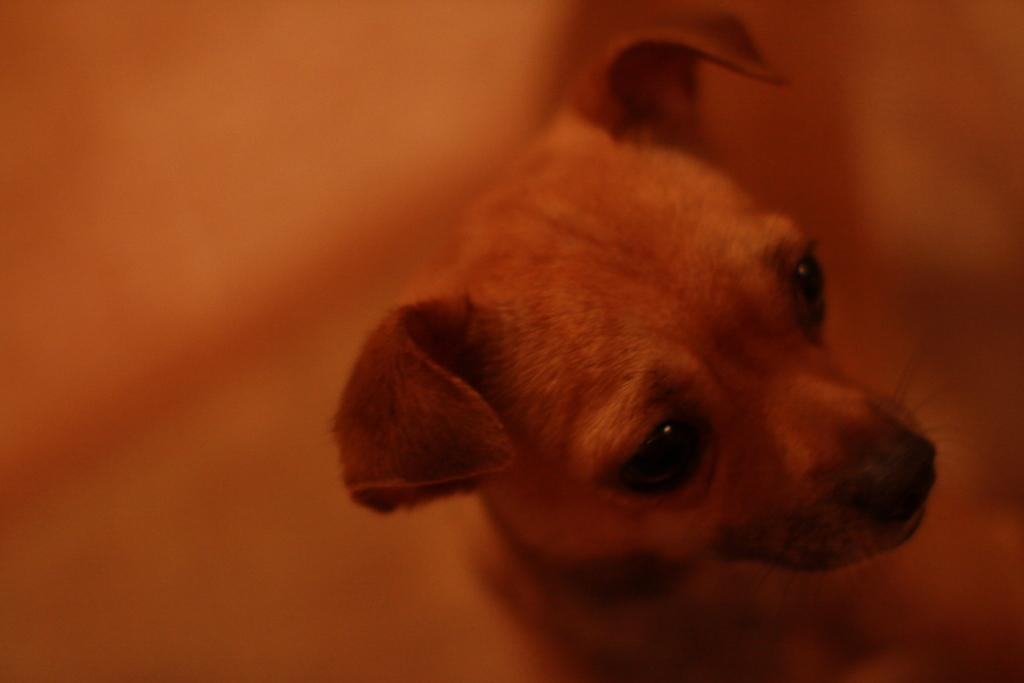What type of animal is present in the image? There is a dog in the image. What type of toothbrush is the dog holding in the image? There is no toothbrush present in the image; it only features a dog. 